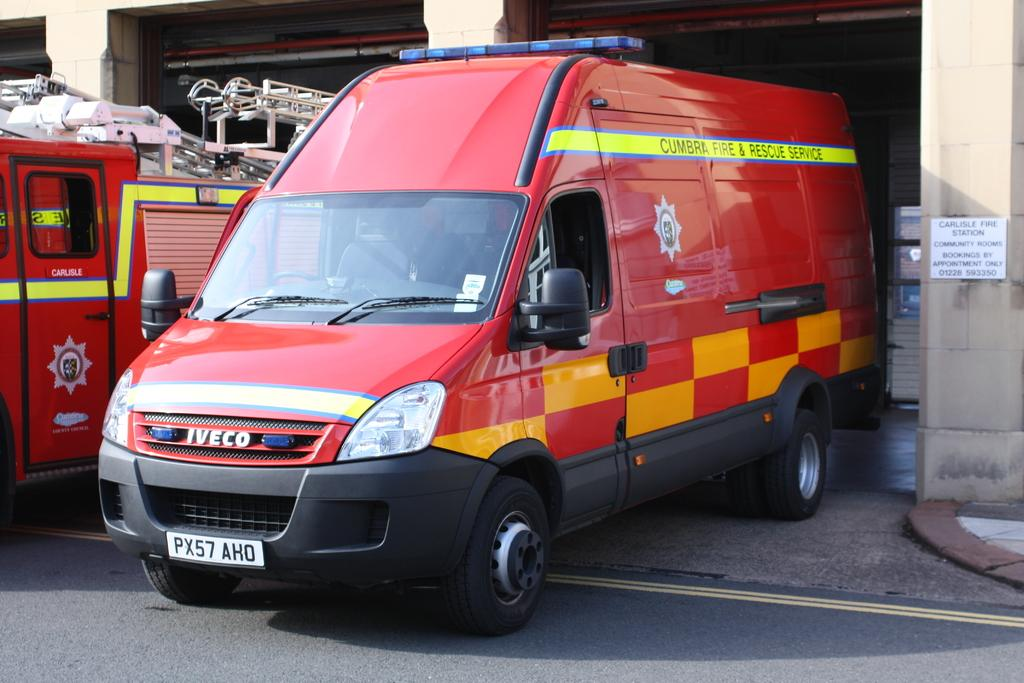<image>
Render a clear and concise summary of the photo. a red truck with checkered colors red and orange on the side 